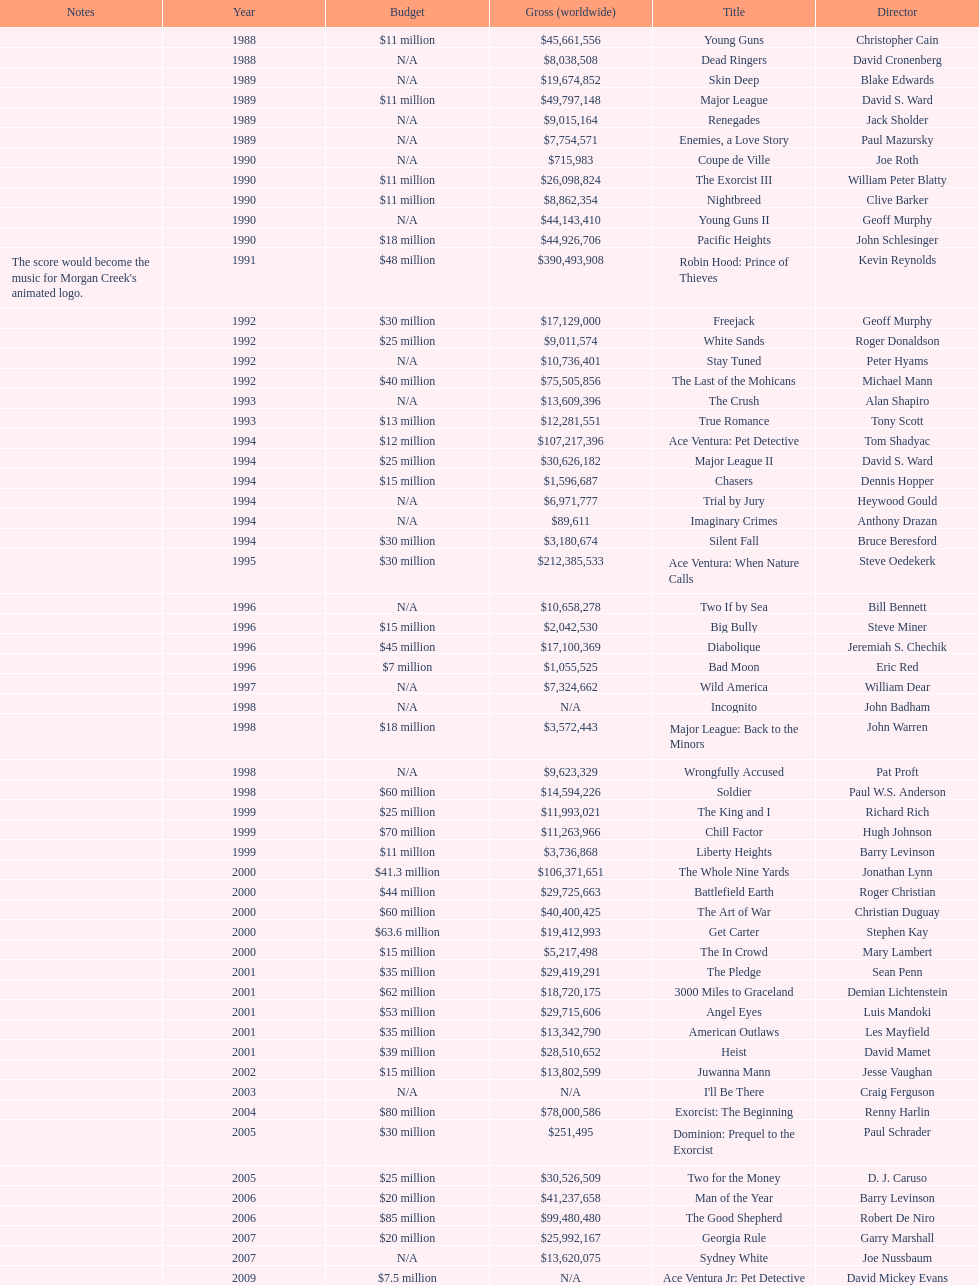After young guns, what was the next movie with the exact same budget? Major League. 